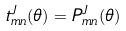Convert formula to latex. <formula><loc_0><loc_0><loc_500><loc_500>t _ { m n } ^ { J } ( \theta ) = P _ { m n } ^ { J } ( \theta )</formula> 